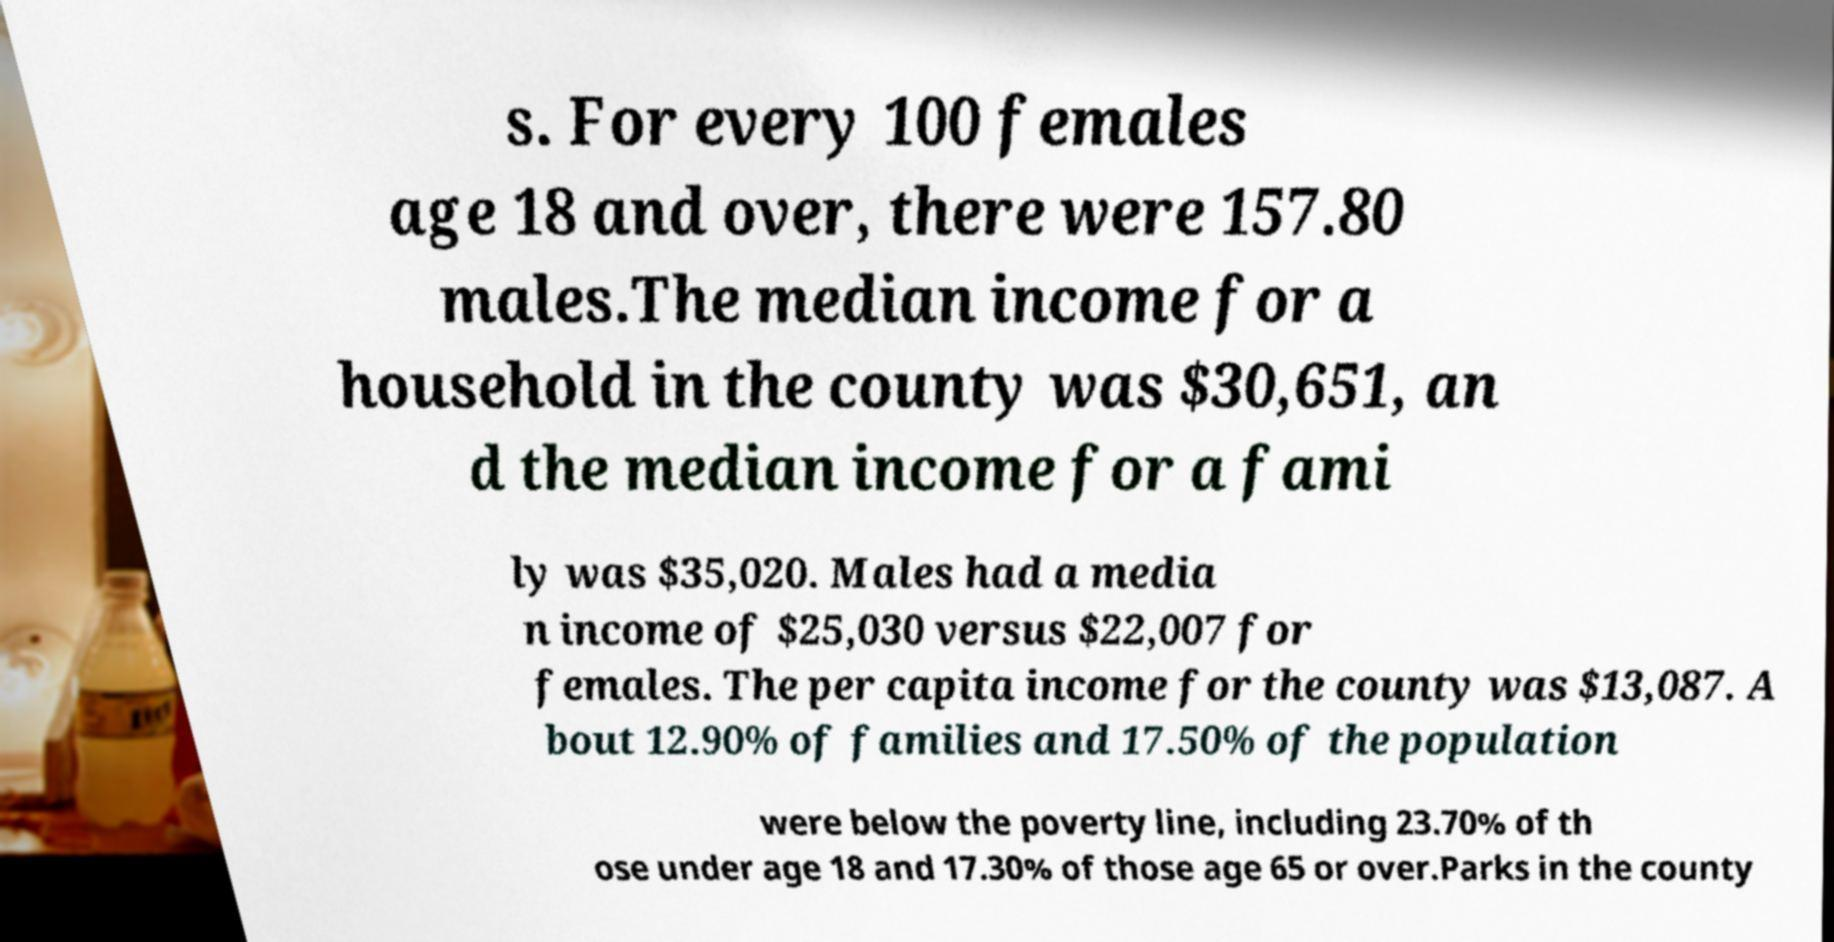For documentation purposes, I need the text within this image transcribed. Could you provide that? s. For every 100 females age 18 and over, there were 157.80 males.The median income for a household in the county was $30,651, an d the median income for a fami ly was $35,020. Males had a media n income of $25,030 versus $22,007 for females. The per capita income for the county was $13,087. A bout 12.90% of families and 17.50% of the population were below the poverty line, including 23.70% of th ose under age 18 and 17.30% of those age 65 or over.Parks in the county 